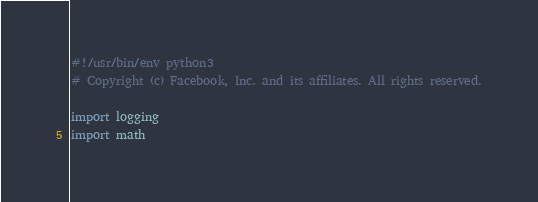<code> <loc_0><loc_0><loc_500><loc_500><_Python_>#!/usr/bin/env python3
# Copyright (c) Facebook, Inc. and its affiliates. All rights reserved.

import logging
import math</code> 